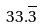<formula> <loc_0><loc_0><loc_500><loc_500>3 3 . \overline { 3 }</formula> 